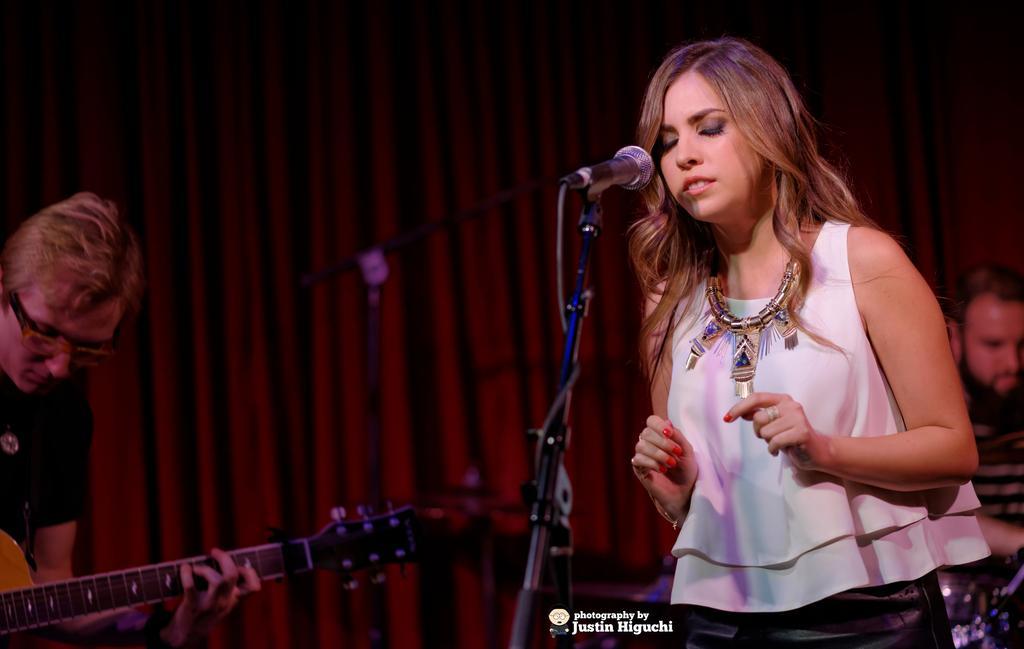In one or two sentences, can you explain what this image depicts? In the image there is a woman in front of mic and at the background there is a man playing guitar and the whole background there is red carpet. 